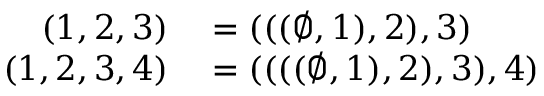<formula> <loc_0><loc_0><loc_500><loc_500>\begin{array} { r l } { ( 1 , 2 , 3 ) } & = ( ( ( \emptyset , 1 ) , 2 ) , 3 ) } \\ { ( 1 , 2 , 3 , 4 ) } & = ( ( ( ( \emptyset , 1 ) , 2 ) , 3 ) , 4 ) } \end{array}</formula> 